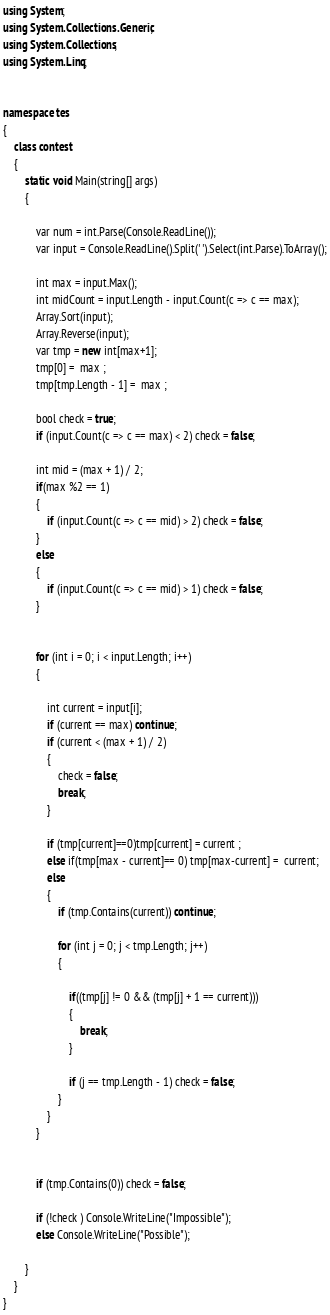Convert code to text. <code><loc_0><loc_0><loc_500><loc_500><_C#_>using System;
using System.Collections.Generic;
using System.Collections;
using System.Linq;


namespace tes
{
	class contest
	{
		static void Main(string[] args)
		{
			 
            var num = int.Parse(Console.ReadLine());
            var input = Console.ReadLine().Split(' ').Select(int.Parse).ToArray();

            int max = input.Max();
            int midCount = input.Length - input.Count(c => c == max);
            Array.Sort(input);
            Array.Reverse(input);
            var tmp = new int[max+1];
            tmp[0] =  max ;
            tmp[tmp.Length - 1] =  max ;

            bool check = true;
            if (input.Count(c => c == max) < 2) check = false; 
            
			int mid = (max + 1) / 2;
            if(max %2 == 1)
            {
                if (input.Count(c => c == mid) > 2) check = false;
            }
            else
            {
                if (input.Count(c => c == mid) > 1) check = false;
            }
           
            
            for (int i = 0; i < input.Length; i++)
            {
               
                int current = input[i];
                if (current == max) continue;
                if (current < (max + 1) / 2)
                {
                    check = false;
                    break;
                }

                if (tmp[current]==0)tmp[current] = current ;
                else if(tmp[max - current]== 0) tmp[max-current] =  current;
                else
                {
					if (tmp.Contains(current)) continue;
					
                    for (int j = 0; j < tmp.Length; j++)
                    {
                        
                        if((tmp[j] != 0 && (tmp[j] + 1 == current)))
                        {
                            break;
                        }

                        if (j == tmp.Length - 1) check = false;
                    }
                }
            }


            if (tmp.Contains(0)) check = false;

            if (!check ) Console.WriteLine("Impossible");
            else Console.WriteLine("Possible");

		}				 
	}
}</code> 